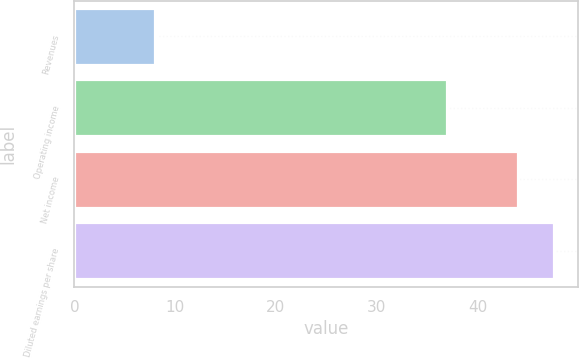Convert chart to OTSL. <chart><loc_0><loc_0><loc_500><loc_500><bar_chart><fcel>Revenues<fcel>Operating income<fcel>Net income<fcel>Diluted earnings per share<nl><fcel>8<fcel>37<fcel>44<fcel>47.6<nl></chart> 